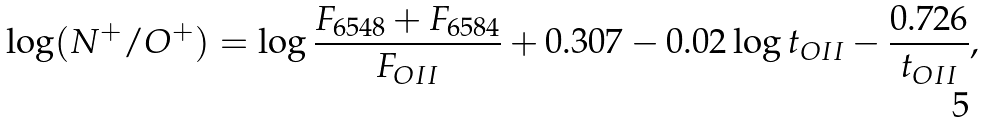Convert formula to latex. <formula><loc_0><loc_0><loc_500><loc_500>\log ( N ^ { + } / O ^ { + } ) = \log \frac { F _ { 6 5 4 8 } + F _ { 6 5 8 4 } } { F _ { O I I } } + 0 . 3 0 7 - 0 . 0 2 \log t _ { O I I } - \frac { 0 . 7 2 6 } { t _ { O I I } } ,</formula> 